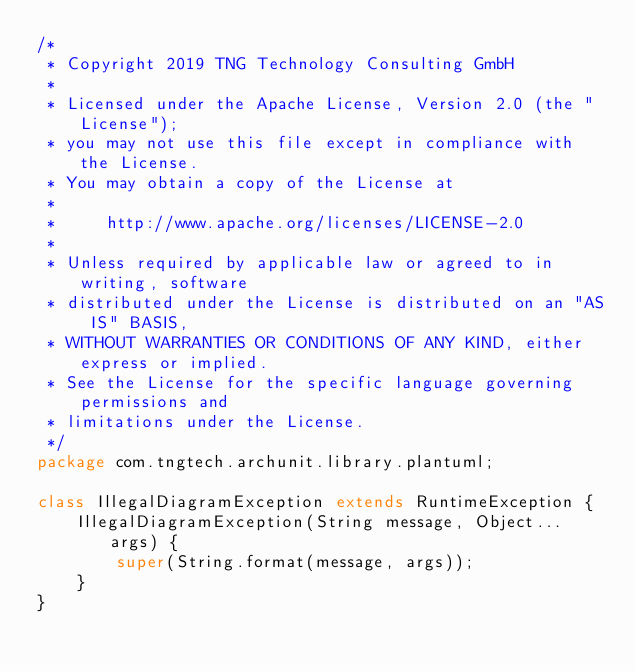Convert code to text. <code><loc_0><loc_0><loc_500><loc_500><_Java_>/*
 * Copyright 2019 TNG Technology Consulting GmbH
 *
 * Licensed under the Apache License, Version 2.0 (the "License");
 * you may not use this file except in compliance with the License.
 * You may obtain a copy of the License at
 *
 *     http://www.apache.org/licenses/LICENSE-2.0
 *
 * Unless required by applicable law or agreed to in writing, software
 * distributed under the License is distributed on an "AS IS" BASIS,
 * WITHOUT WARRANTIES OR CONDITIONS OF ANY KIND, either express or implied.
 * See the License for the specific language governing permissions and
 * limitations under the License.
 */
package com.tngtech.archunit.library.plantuml;

class IllegalDiagramException extends RuntimeException {
    IllegalDiagramException(String message, Object... args) {
        super(String.format(message, args));
    }
}
</code> 